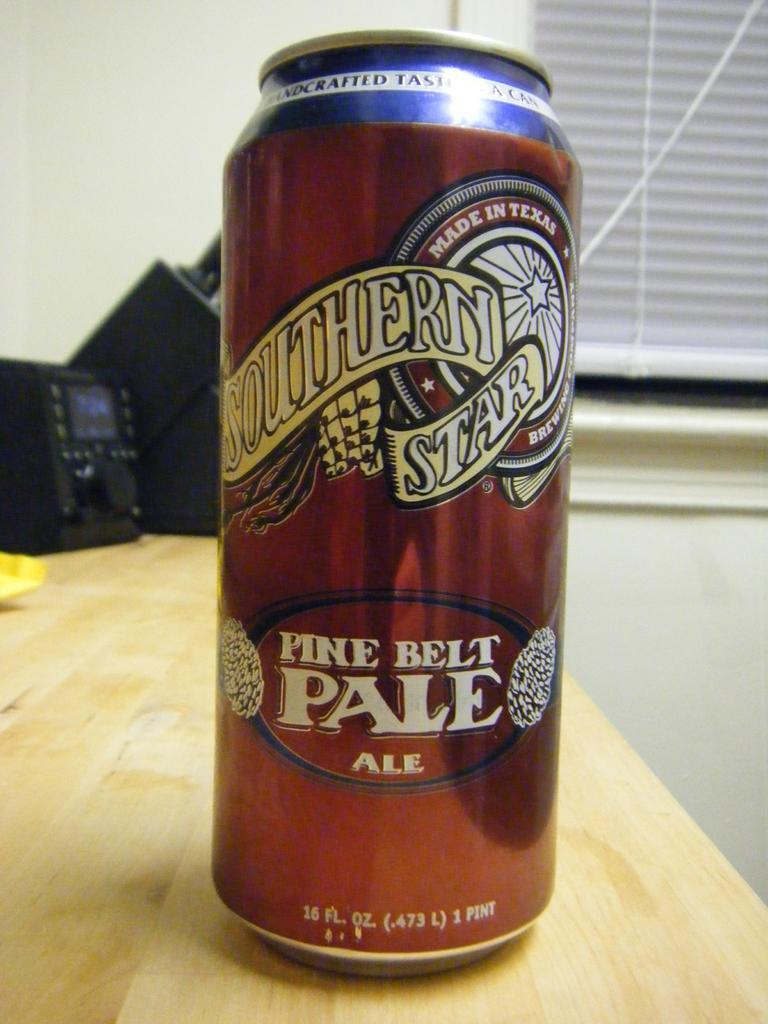<image>
Relay a brief, clear account of the picture shown. a aluminum can of southern star pine belt ale 